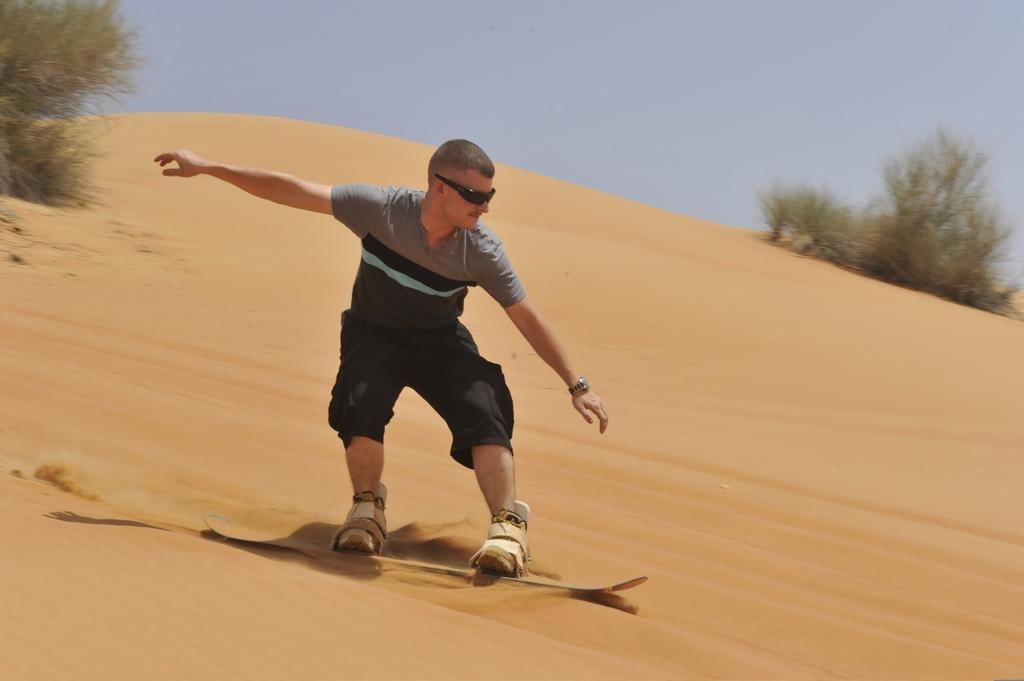Who or what is the main subject in the image? There is a person in the image. What activity is the person engaged in? The person is skating on sand. What can be seen in the background of the image? There are plants and the sky visible in the background of the image. What type of marble is being used by the laborer in the image? There is no laborer or marble present in the image. In which direction is the person skating on sand? The direction in which the person is skating on sand cannot be determined from the image alone. 